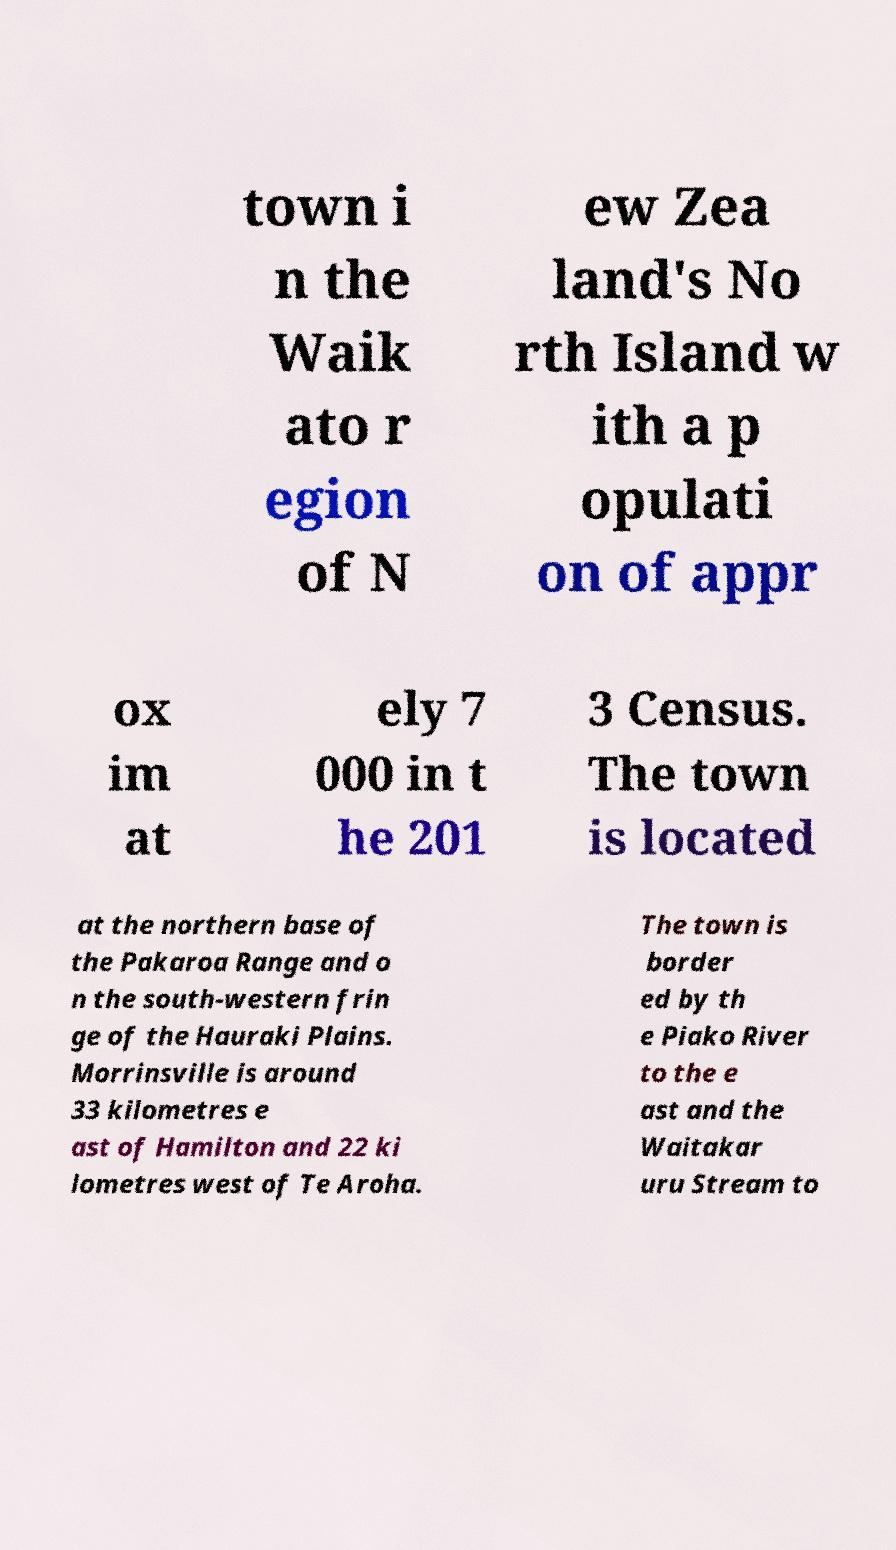Please read and relay the text visible in this image. What does it say? town i n the Waik ato r egion of N ew Zea land's No rth Island w ith a p opulati on of appr ox im at ely 7 000 in t he 201 3 Census. The town is located at the northern base of the Pakaroa Range and o n the south-western frin ge of the Hauraki Plains. Morrinsville is around 33 kilometres e ast of Hamilton and 22 ki lometres west of Te Aroha. The town is border ed by th e Piako River to the e ast and the Waitakar uru Stream to 